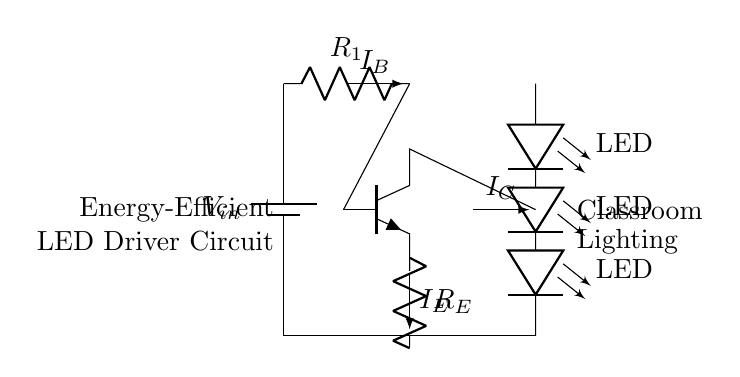What is the type of transistor used in this circuit? The circuit diagram shows an npn transistor, which is indicated by the designation "npn" next to the transistor symbol.
Answer: npn What is the role of the resistor labeled R1? R1 is connected to the base of the npn transistor, which suggests that its role is to limit the base current to control the operation of the transistor.
Answer: Limit base current How many LEDs are in the LED array? The circuit diagram clearly shows three LED symbols connected in series between the high supply voltage and ground.
Answer: Three What is the purpose of resistor R_E? R_E is connected to the emitter of the transistor and helps to stabilize the transistor's operation by providing feedback and setting the emitter current.
Answer: Stabilization What is the direction of current I_B? The notation on the circuit indicates that I_B flows into the base of the transistor, as shown by the arrow pointing to the base.
Answer: Into the base What happens if R1 is increased in value? Increasing the value of R1 will decrease the base current I_B, which in turn may reduce the collector current I_C and affect the operation of the transistor, potentially leading to less light output from the LEDs.
Answer: Reduced light output What does the circuit primarily drive? The primary function of this circuit is to drive an array of LEDs for classroom lighting, as indicated by the labels and the connections.
Answer: LED lighting 